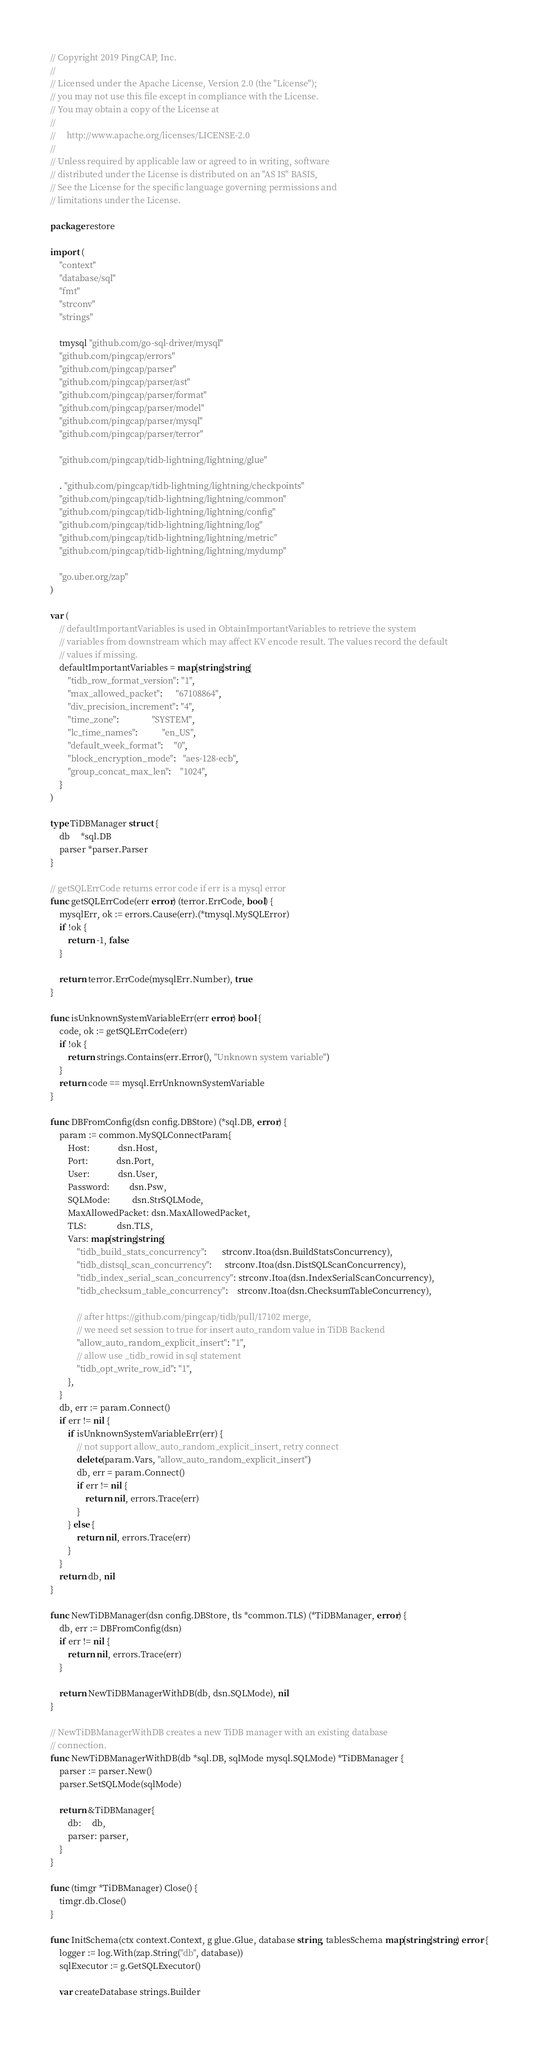<code> <loc_0><loc_0><loc_500><loc_500><_Go_>// Copyright 2019 PingCAP, Inc.
//
// Licensed under the Apache License, Version 2.0 (the "License");
// you may not use this file except in compliance with the License.
// You may obtain a copy of the License at
//
//     http://www.apache.org/licenses/LICENSE-2.0
//
// Unless required by applicable law or agreed to in writing, software
// distributed under the License is distributed on an "AS IS" BASIS,
// See the License for the specific language governing permissions and
// limitations under the License.

package restore

import (
	"context"
	"database/sql"
	"fmt"
	"strconv"
	"strings"

	tmysql "github.com/go-sql-driver/mysql"
	"github.com/pingcap/errors"
	"github.com/pingcap/parser"
	"github.com/pingcap/parser/ast"
	"github.com/pingcap/parser/format"
	"github.com/pingcap/parser/model"
	"github.com/pingcap/parser/mysql"
	"github.com/pingcap/parser/terror"

	"github.com/pingcap/tidb-lightning/lightning/glue"

	. "github.com/pingcap/tidb-lightning/lightning/checkpoints"
	"github.com/pingcap/tidb-lightning/lightning/common"
	"github.com/pingcap/tidb-lightning/lightning/config"
	"github.com/pingcap/tidb-lightning/lightning/log"
	"github.com/pingcap/tidb-lightning/lightning/metric"
	"github.com/pingcap/tidb-lightning/lightning/mydump"

	"go.uber.org/zap"
)

var (
	// defaultImportantVariables is used in ObtainImportantVariables to retrieve the system
	// variables from downstream which may affect KV encode result. The values record the default
	// values if missing.
	defaultImportantVariables = map[string]string{
		"tidb_row_format_version": "1",
		"max_allowed_packet":      "67108864",
		"div_precision_increment": "4",
		"time_zone":               "SYSTEM",
		"lc_time_names":           "en_US",
		"default_week_format":     "0",
		"block_encryption_mode":   "aes-128-ecb",
		"group_concat_max_len":    "1024",
	}
)

type TiDBManager struct {
	db     *sql.DB
	parser *parser.Parser
}

// getSQLErrCode returns error code if err is a mysql error
func getSQLErrCode(err error) (terror.ErrCode, bool) {
	mysqlErr, ok := errors.Cause(err).(*tmysql.MySQLError)
	if !ok {
		return -1, false
	}

	return terror.ErrCode(mysqlErr.Number), true
}

func isUnknownSystemVariableErr(err error) bool {
	code, ok := getSQLErrCode(err)
	if !ok {
		return strings.Contains(err.Error(), "Unknown system variable")
	}
	return code == mysql.ErrUnknownSystemVariable
}

func DBFromConfig(dsn config.DBStore) (*sql.DB, error) {
	param := common.MySQLConnectParam{
		Host:             dsn.Host,
		Port:             dsn.Port,
		User:             dsn.User,
		Password:         dsn.Psw,
		SQLMode:          dsn.StrSQLMode,
		MaxAllowedPacket: dsn.MaxAllowedPacket,
		TLS:              dsn.TLS,
		Vars: map[string]string{
			"tidb_build_stats_concurrency":       strconv.Itoa(dsn.BuildStatsConcurrency),
			"tidb_distsql_scan_concurrency":      strconv.Itoa(dsn.DistSQLScanConcurrency),
			"tidb_index_serial_scan_concurrency": strconv.Itoa(dsn.IndexSerialScanConcurrency),
			"tidb_checksum_table_concurrency":    strconv.Itoa(dsn.ChecksumTableConcurrency),

			// after https://github.com/pingcap/tidb/pull/17102 merge,
			// we need set session to true for insert auto_random value in TiDB Backend
			"allow_auto_random_explicit_insert": "1",
			// allow use _tidb_rowid in sql statement
			"tidb_opt_write_row_id": "1",
		},
	}
	db, err := param.Connect()
	if err != nil {
		if isUnknownSystemVariableErr(err) {
			// not support allow_auto_random_explicit_insert, retry connect
			delete(param.Vars, "allow_auto_random_explicit_insert")
			db, err = param.Connect()
			if err != nil {
				return nil, errors.Trace(err)
			}
		} else {
			return nil, errors.Trace(err)
		}
	}
	return db, nil
}

func NewTiDBManager(dsn config.DBStore, tls *common.TLS) (*TiDBManager, error) {
	db, err := DBFromConfig(dsn)
	if err != nil {
		return nil, errors.Trace(err)
	}

	return NewTiDBManagerWithDB(db, dsn.SQLMode), nil
}

// NewTiDBManagerWithDB creates a new TiDB manager with an existing database
// connection.
func NewTiDBManagerWithDB(db *sql.DB, sqlMode mysql.SQLMode) *TiDBManager {
	parser := parser.New()
	parser.SetSQLMode(sqlMode)

	return &TiDBManager{
		db:     db,
		parser: parser,
	}
}

func (timgr *TiDBManager) Close() {
	timgr.db.Close()
}

func InitSchema(ctx context.Context, g glue.Glue, database string, tablesSchema map[string]string) error {
	logger := log.With(zap.String("db", database))
	sqlExecutor := g.GetSQLExecutor()

	var createDatabase strings.Builder</code> 